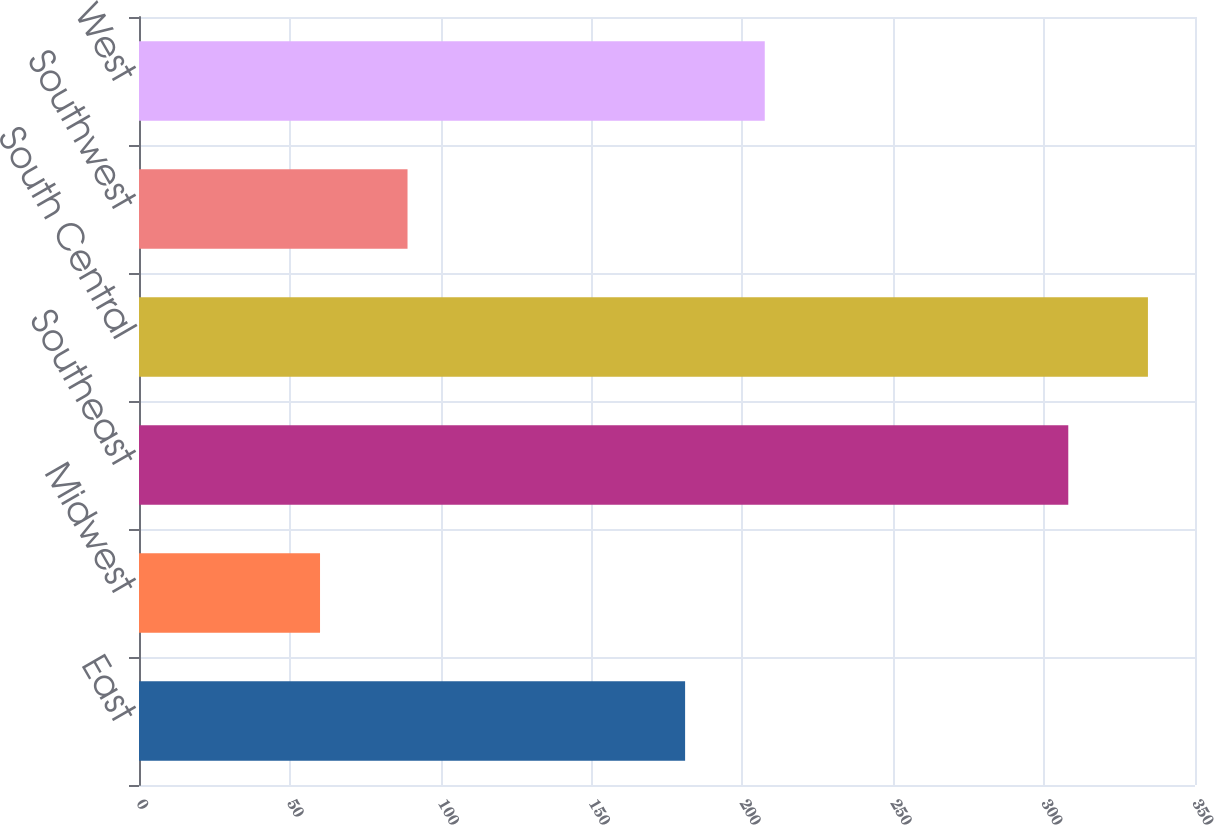<chart> <loc_0><loc_0><loc_500><loc_500><bar_chart><fcel>East<fcel>Midwest<fcel>Southeast<fcel>South Central<fcel>Southwest<fcel>West<nl><fcel>181<fcel>60<fcel>308<fcel>334.4<fcel>89<fcel>207.4<nl></chart> 